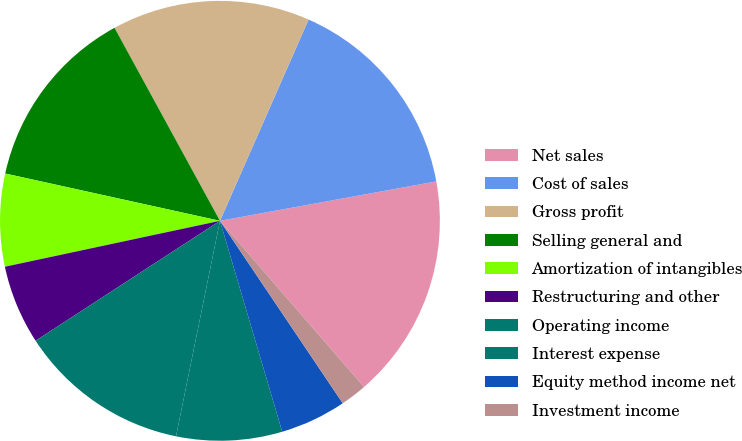Convert chart. <chart><loc_0><loc_0><loc_500><loc_500><pie_chart><fcel>Net sales<fcel>Cost of sales<fcel>Gross profit<fcel>Selling general and<fcel>Amortization of intangibles<fcel>Restructuring and other<fcel>Operating income<fcel>Interest expense<fcel>Equity method income net<fcel>Investment income<nl><fcel>16.5%<fcel>15.53%<fcel>14.56%<fcel>13.59%<fcel>6.8%<fcel>5.83%<fcel>12.62%<fcel>7.77%<fcel>4.86%<fcel>1.94%<nl></chart> 